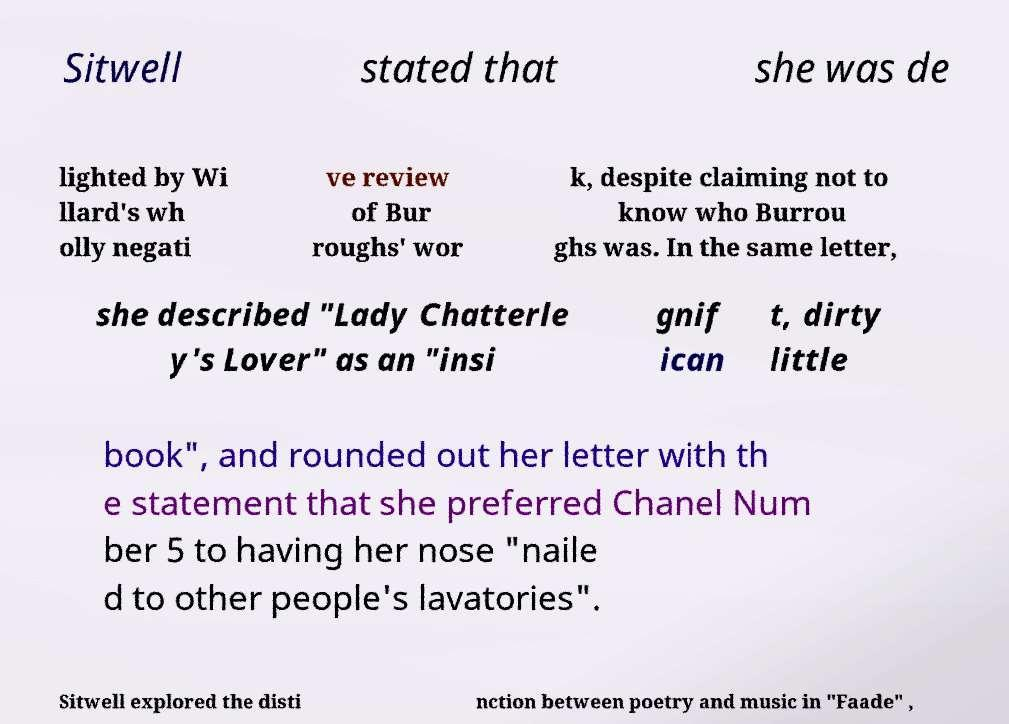There's text embedded in this image that I need extracted. Can you transcribe it verbatim? Sitwell stated that she was de lighted by Wi llard's wh olly negati ve review of Bur roughs' wor k, despite claiming not to know who Burrou ghs was. In the same letter, she described "Lady Chatterle y's Lover" as an "insi gnif ican t, dirty little book", and rounded out her letter with th e statement that she preferred Chanel Num ber 5 to having her nose "naile d to other people's lavatories". Sitwell explored the disti nction between poetry and music in "Faade" , 